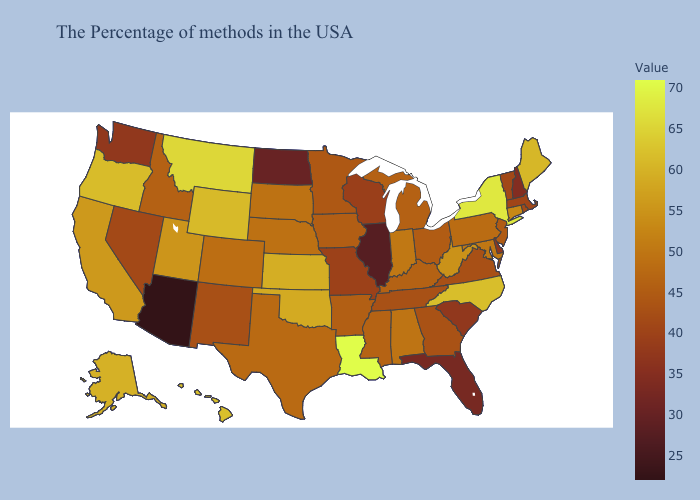Does Wyoming have the lowest value in the USA?
Answer briefly. No. Does Connecticut have a higher value than Wyoming?
Give a very brief answer. No. Does Kansas have the highest value in the MidWest?
Give a very brief answer. Yes. Among the states that border New Hampshire , which have the highest value?
Short answer required. Maine. Which states have the lowest value in the USA?
Concise answer only. Arizona. 